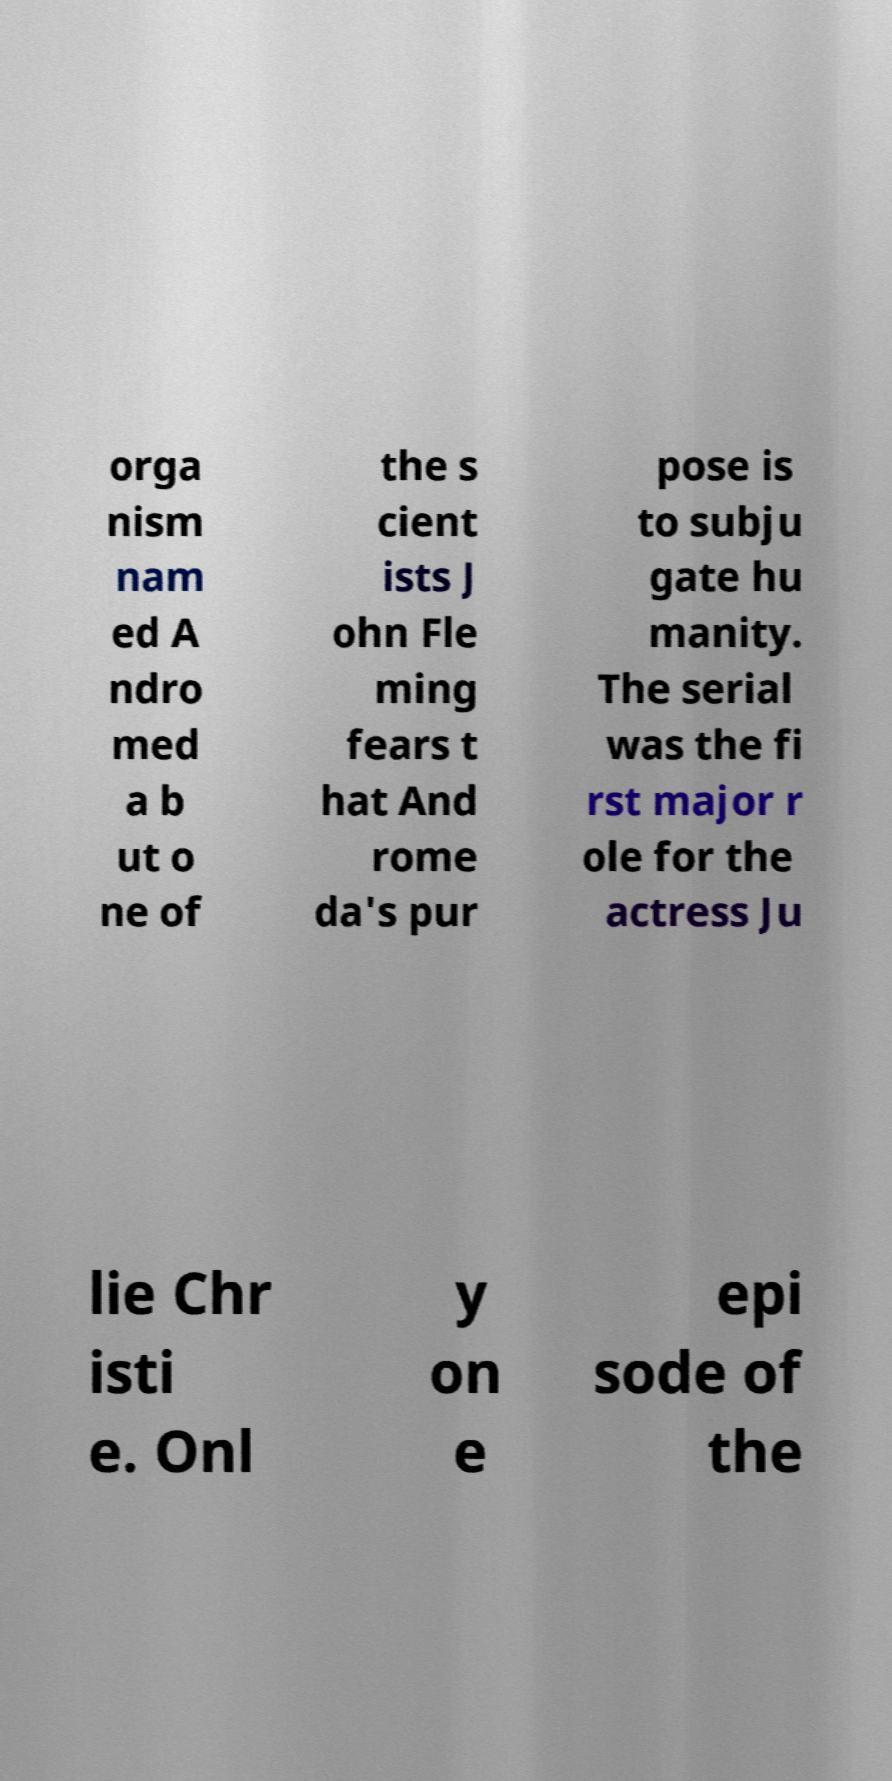Can you accurately transcribe the text from the provided image for me? orga nism nam ed A ndro med a b ut o ne of the s cient ists J ohn Fle ming fears t hat And rome da's pur pose is to subju gate hu manity. The serial was the fi rst major r ole for the actress Ju lie Chr isti e. Onl y on e epi sode of the 